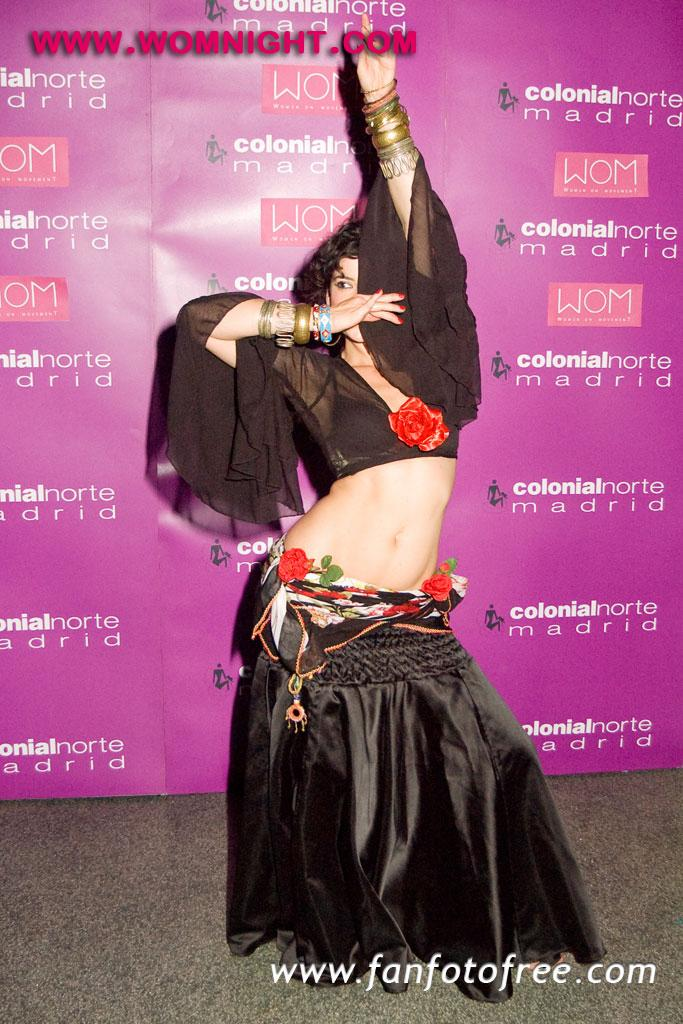What is the main subject of the image? There is a woman standing in the image. Where is the woman standing? The woman is standing on the ground. What can be seen in the background of the image? There is a banner with text in the background of the image. What type of tub is visible in the image? There is no tub present in the image. Who is the owner of the woman in the image? The image does not provide information about the woman's ownership, and it is not appropriate to assume or speculate about such matters. --- Facts: 1. There is a car in the image. 2. The car is parked on the street. 3. There are trees in the background of the image. 4. The sky is visible in the image. Absurd Topics: parrot, dance, engine Conversation: What is the main subject of the image? There is a car in the image. Where is the car located? The car is parked on the street. What can be seen in the background of the image? There are trees in the background of the image. What is visible above the car in the image? The sky is visible in the image. Reasoning: Let's think step by step in order to produce the conversation. We start by identifying the main subject of the image, which is the car. Then, we describe the car's location, which is parked on the street. Next, we mention the presence of trees in the background, providing additional context for the image. Finally, we acknowledge the presence of the sky above the car, which is visible in the image. Absurd Question/Answer: Can you tell me how many parrots are sitting on the car in the image? There are no parrots present in the image. What type of dance is the car performing in the image? Cars do not perform dances; they are inanimate objects. 